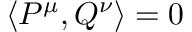<formula> <loc_0><loc_0><loc_500><loc_500>\left \langle P ^ { \mu } , Q ^ { \nu } \right \rangle = 0</formula> 